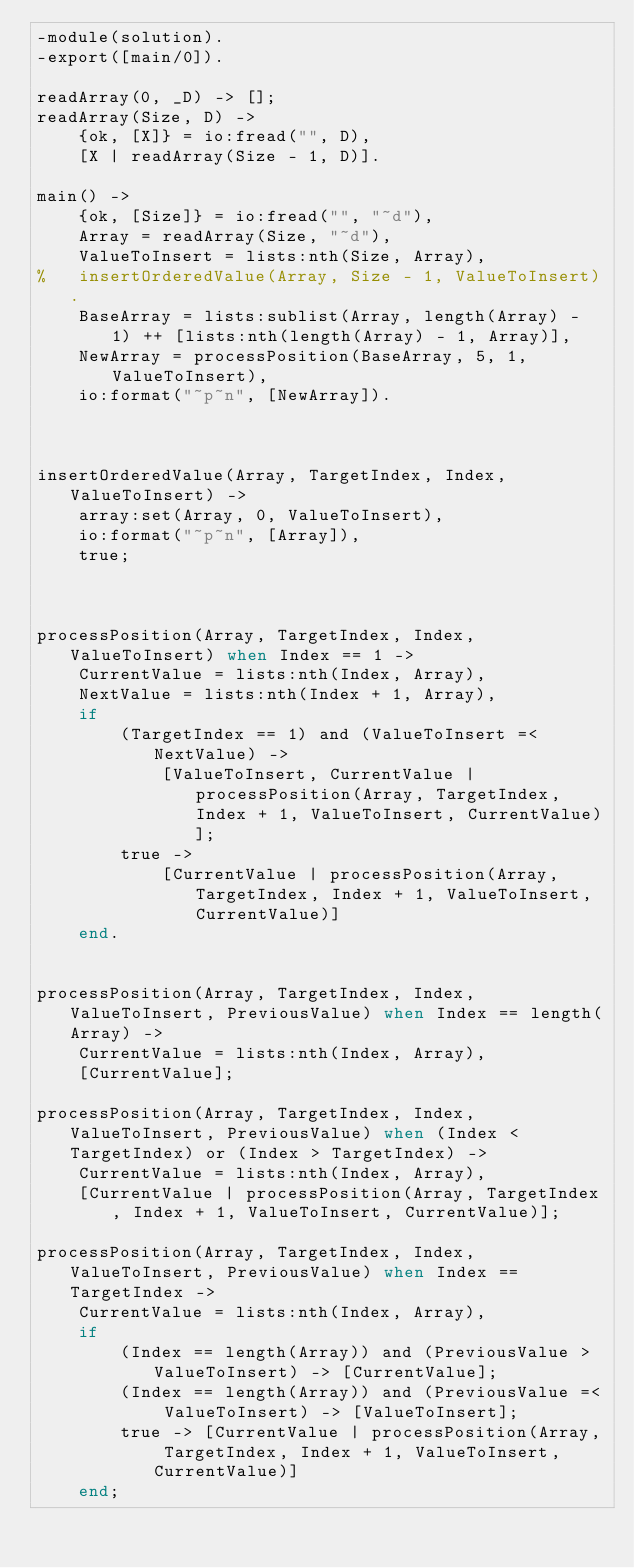<code> <loc_0><loc_0><loc_500><loc_500><_Erlang_>-module(solution).
-export([main/0]).

readArray(0, _D) -> [];
readArray(Size, D) -> 
    {ok, [X]} = io:fread("", D),
    [X | readArray(Size - 1, D)].

main() ->
    {ok, [Size]} = io:fread("", "~d"),
    Array = readArray(Size, "~d"),
	ValueToInsert = lists:nth(Size, Array),
%	insertOrderedValue(Array, Size - 1, ValueToInsert).
	BaseArray = lists:sublist(Array, length(Array) - 1) ++ [lists:nth(length(Array) - 1, Array)],
	NewArray = processPosition(BaseArray, 5, 1, ValueToInsert),
	io:format("~p~n", [NewArray]).



insertOrderedValue(Array, TargetIndex, Index, ValueToInsert) ->
	array:set(Array, 0, ValueToInsert),
	io:format("~p~n", [Array]),
	true;



processPosition(Array, TargetIndex, Index, ValueToInsert) when Index == 1 ->
	CurrentValue = lists:nth(Index, Array),
	NextValue = lists:nth(Index + 1, Array),
	if
		(TargetIndex == 1) and (ValueToInsert =< NextValue) -> 
			[ValueToInsert, CurrentValue | processPosition(Array, TargetIndex, Index + 1, ValueToInsert, CurrentValue)];
		true -> 
			[CurrentValue | processPosition(Array, TargetIndex, Index + 1, ValueToInsert, CurrentValue)]
	end.


processPosition(Array, TargetIndex, Index, ValueToInsert, PreviousValue) when Index == length(Array) ->
	CurrentValue = lists:nth(Index, Array),
	[CurrentValue];

processPosition(Array, TargetIndex, Index, ValueToInsert, PreviousValue) when (Index < TargetIndex) or (Index > TargetIndex) ->
	CurrentValue = lists:nth(Index, Array),
	[CurrentValue | processPosition(Array, TargetIndex, Index + 1, ValueToInsert, CurrentValue)];

processPosition(Array, TargetIndex, Index, ValueToInsert, PreviousValue) when Index == TargetIndex ->
	CurrentValue = lists:nth(Index, Array),
	if
		(Index == length(Array)) and (PreviousValue > ValueToInsert) -> [CurrentValue];
		(Index == length(Array)) and (PreviousValue =< ValueToInsert) -> [ValueToInsert];
		true -> [CurrentValue | processPosition(Array, TargetIndex, Index + 1, ValueToInsert, CurrentValue)]
	end;

</code> 